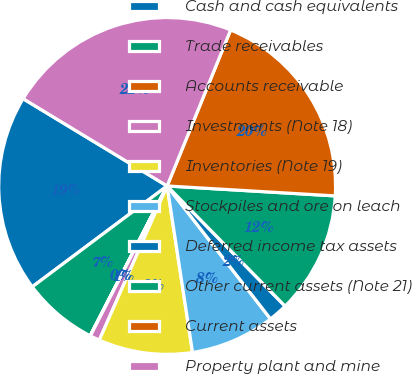<chart> <loc_0><loc_0><loc_500><loc_500><pie_chart><fcel>Cash and cash equivalents<fcel>Trade receivables<fcel>Accounts receivable<fcel>Investments (Note 18)<fcel>Inventories (Note 19)<fcel>Stockpiles and ore on leach<fcel>Deferred income tax assets<fcel>Other current assets (Note 21)<fcel>Current assets<fcel>Property plant and mine<nl><fcel>18.89%<fcel>7.22%<fcel>0.03%<fcel>0.93%<fcel>9.01%<fcel>8.11%<fcel>1.83%<fcel>11.71%<fcel>19.79%<fcel>22.48%<nl></chart> 